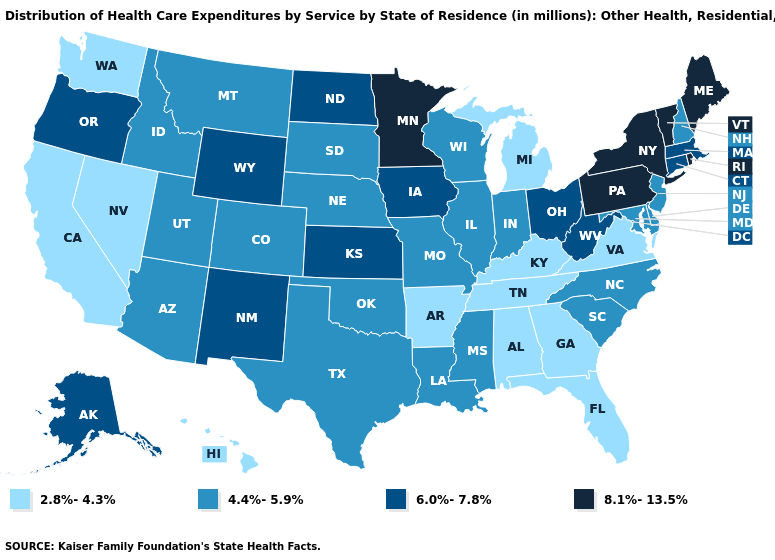What is the value of Missouri?
Give a very brief answer. 4.4%-5.9%. Among the states that border Kansas , which have the lowest value?
Concise answer only. Colorado, Missouri, Nebraska, Oklahoma. What is the value of North Dakota?
Quick response, please. 6.0%-7.8%. Among the states that border Wisconsin , which have the lowest value?
Concise answer only. Michigan. Does Indiana have the same value as Alaska?
Give a very brief answer. No. What is the lowest value in the USA?
Short answer required. 2.8%-4.3%. Which states have the highest value in the USA?
Give a very brief answer. Maine, Minnesota, New York, Pennsylvania, Rhode Island, Vermont. What is the value of New York?
Quick response, please. 8.1%-13.5%. Does Connecticut have a lower value than Arizona?
Quick response, please. No. Among the states that border Pennsylvania , does Delaware have the lowest value?
Give a very brief answer. Yes. Name the states that have a value in the range 4.4%-5.9%?
Give a very brief answer. Arizona, Colorado, Delaware, Idaho, Illinois, Indiana, Louisiana, Maryland, Mississippi, Missouri, Montana, Nebraska, New Hampshire, New Jersey, North Carolina, Oklahoma, South Carolina, South Dakota, Texas, Utah, Wisconsin. What is the value of Massachusetts?
Answer briefly. 6.0%-7.8%. Which states have the lowest value in the Northeast?
Be succinct. New Hampshire, New Jersey. Does Connecticut have the lowest value in the USA?
Be succinct. No. Does Connecticut have a lower value than New York?
Be succinct. Yes. 